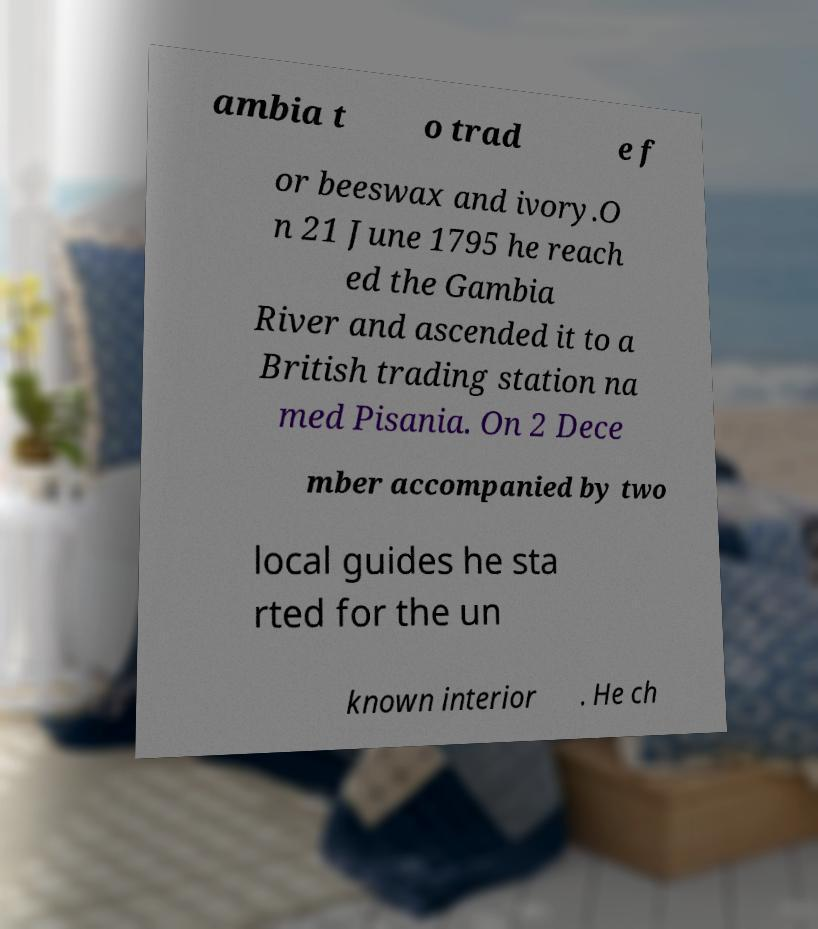For documentation purposes, I need the text within this image transcribed. Could you provide that? ambia t o trad e f or beeswax and ivory.O n 21 June 1795 he reach ed the Gambia River and ascended it to a British trading station na med Pisania. On 2 Dece mber accompanied by two local guides he sta rted for the un known interior . He ch 